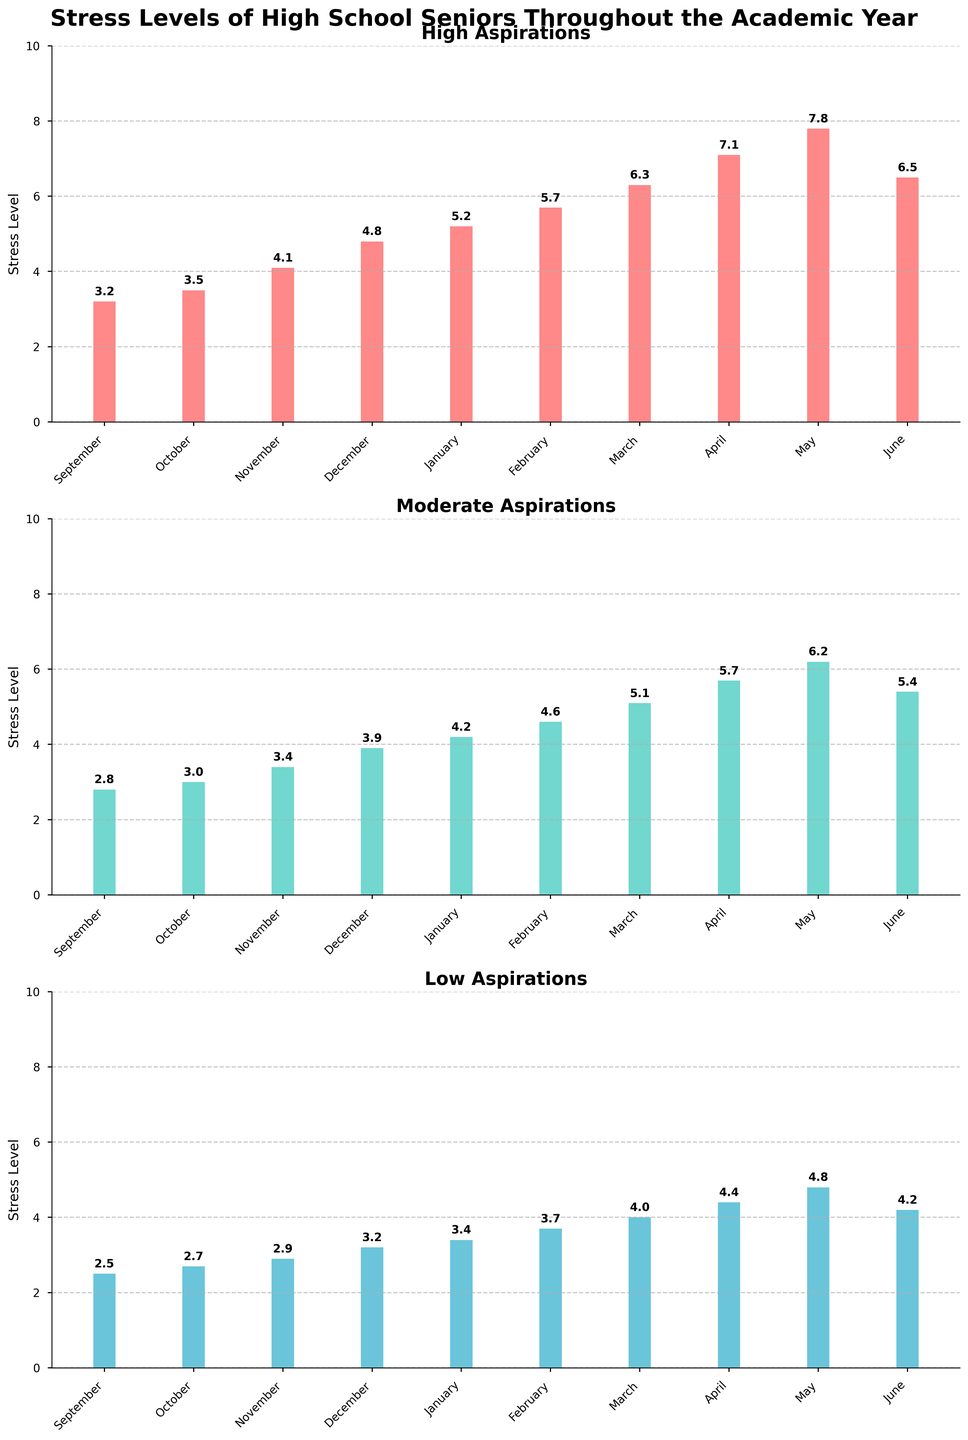What trend can you observe in the stress levels of students with high aspirations from September to June? From September to April, the stress levels of students with high aspirations steadily increase, peaking in May. Then, there is a slight decrease in June.
Answer: Steady increase, peaking in May, slight decrease in June Compare the stress levels of students with low aspirations in May to those with moderate aspirations in the same month. Which group has higher stress levels? In May, the stress level for low aspirations is 4.8, while for moderate aspirations, it is 6.2. This shows that students with moderate aspirations have higher stress levels.
Answer: Moderate aspirations What is the difference in stress levels between students with high aspirations in June and students with low aspirations in June? The stress level for high aspirations in June is 6.5, and for low aspirations, it is 4.2. The difference is 6.5 - 4.2 = 2.3.
Answer: 2.3 What is the average stress level for students with high aspirations over the entire academic year? Sum of monthly stress levels for high aspirations: 3.2 + 3.5 + 4.1 + 4.8 + 5.2 + 5.7 + 6.3 + 7.1 + 7.8 + 6.5 = 54.2. There are 10 months, so 54.2 / 10 = 5.42.
Answer: 5.42 In which month do students with moderate aspirations experience their peak stress levels, and what is the value? The stress level for moderate aspirations peaks in May at 6.2, as this is the highest value observed in the chart.
Answer: May, 6.2 By how much does the stress level of students with low aspirations increase from September to May? Stress levels in September are 2.5, and in May are 4.8. Therefore, the increase is 4.8 - 2.5 = 2.3.
Answer: 2.3 What visual differences can you observe between the bar heights of students with moderate aspirations in February and June? The bar in February is slightly taller, representing a stress level of 4.6, while the bar in June is shorter, representing a stress level of 5.4. This indicates a lower stress level in February compared to June.
Answer: February bar is taller, representing lower stress Which group experienced the largest increase in stress levels from January to April, and how much was this increase? High aspirations: 7.1 - 5.2 = 1.9, Moderate aspirations: 5.7 - 4.2 = 1.5, Low aspirations: 4.4 - 3.4 = 1.0. The high aspirations group experienced the largest increase of 1.9.
Answer: High aspirations, 1.9 Summarize the change in stress levels for students with low aspirations from January to June. The stress levels for students with low aspirations show a steady increase from January (3.4) to May (4.8) and then a slight decrease in June (4.2).
Answer: Steady increase, then a slight decrease 